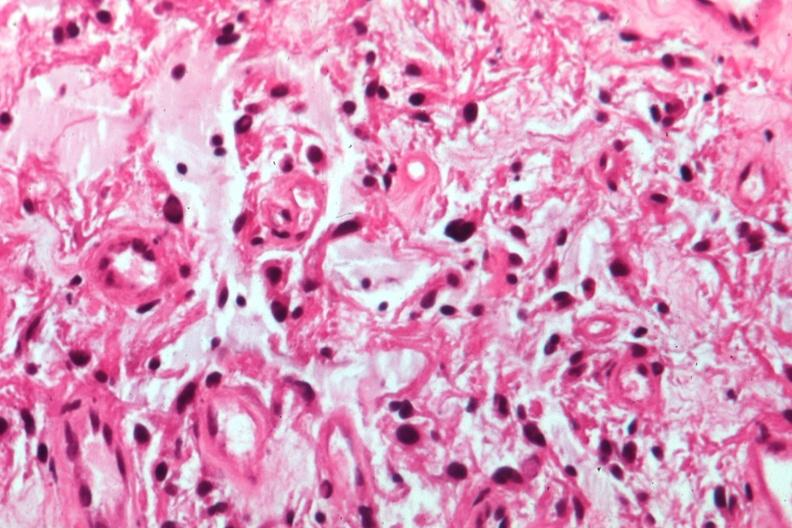s chronic ischemia present?
Answer the question using a single word or phrase. No 